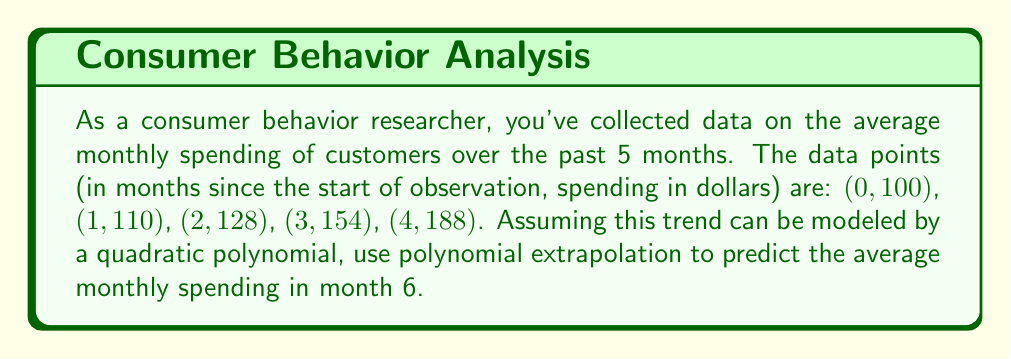Solve this math problem. 1) We need to find a quadratic polynomial of the form $f(x) = ax^2 + bx + c$ that fits the given data points.

2) We can use the method of least squares to find the best-fit quadratic polynomial. However, for simplicity, we'll use three points to determine the coefficients: (0, 100), (2, 128), and (4, 188).

3) Substituting these points into the general form:

   $100 = a(0)^2 + b(0) + c$
   $128 = a(2)^2 + b(2) + c$
   $188 = a(4)^2 + b(4) + c$

4) Simplifying:

   $100 = c$
   $128 = 4a + 2b + c$
   $188 = 16a + 4b + c$

5) Subtracting the first equation from the second and third:

   $28 = 4a + 2b$
   $88 = 16a + 4b$

6) Multiplying the first equation by 2 and subtracting from the second:

   $56 = 8a + 4b$
   $88 = 16a + 4b$
   $32 = 8a$

7) Solving for $a$:

   $a = 4$

8) Substituting back to find $b$:

   $28 = 4(4) + 2b$
   $28 = 16 + 2b$
   $12 = 2b$
   $b = 6$

9) Therefore, our quadratic polynomial is:

   $f(x) = 4x^2 + 6x + 100$

10) To predict the spending in month 6, we substitute $x = 6$:

    $f(6) = 4(6)^2 + 6(6) + 100$
    $f(6) = 4(36) + 36 + 100$
    $f(6) = 144 + 36 + 100$
    $f(6) = 280$

Thus, the predicted average monthly spending in month 6 is $280.
Answer: $280 